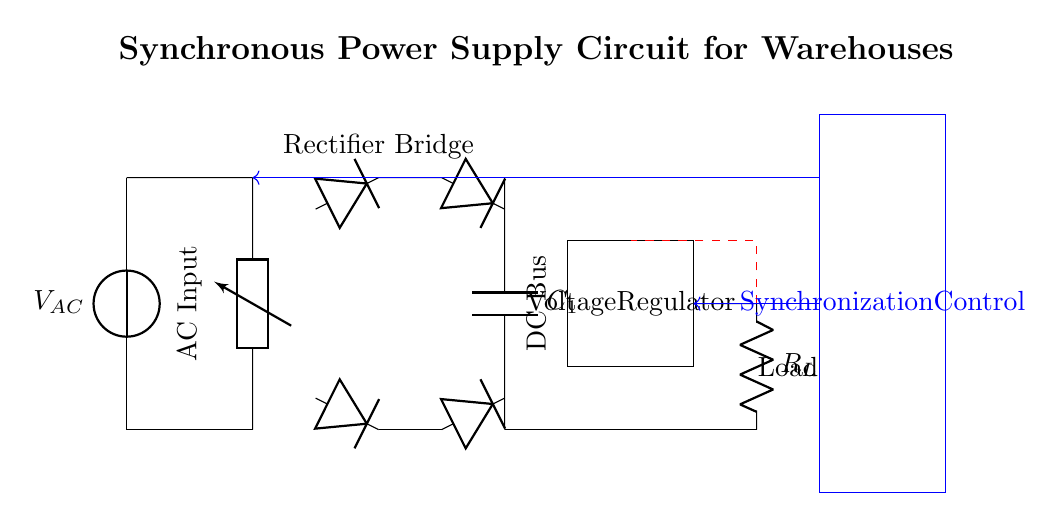What is the type of the main power source? The main power source is an AC voltage source indicated by the symbol for a voltage source labeled V_AC.
Answer: AC voltage source What component is responsible for converting AC to DC in this circuit? The rectifier bridge, represented by four diodes connected in a specific arrangement, converts AC voltage to DC voltage.
Answer: Rectifier bridge How many diodes are used in the rectifier bridge? There are four diodes used in the rectifier bridge, as indicated by the four diode symbols in the diagram.
Answer: Four diodes What is the purpose of the smoothing capacitor? The smoothing capacitor, labeled C_1, is used to reduce the ripple in the DC output voltage after rectification.
Answer: Reduce ripple Which component regulates the output voltage? The voltage regulator, depicted as a rectangle labeled "Voltage Regulator," is responsible for maintaining a constant output voltage level.
Answer: Voltage regulator What does the blue rectangle represent in the circuit? The blue rectangle represents the synchronization control, indicating a block responsible for managing the synchronizing functions within the power supply circuit.
Answer: Synchronization control What does the feedback loop in the circuit indicate? The red dashed line represents a feedback loop used to monitor the output voltage and make adjustments to ensure stable operation of the power supply.
Answer: Feedback loop 